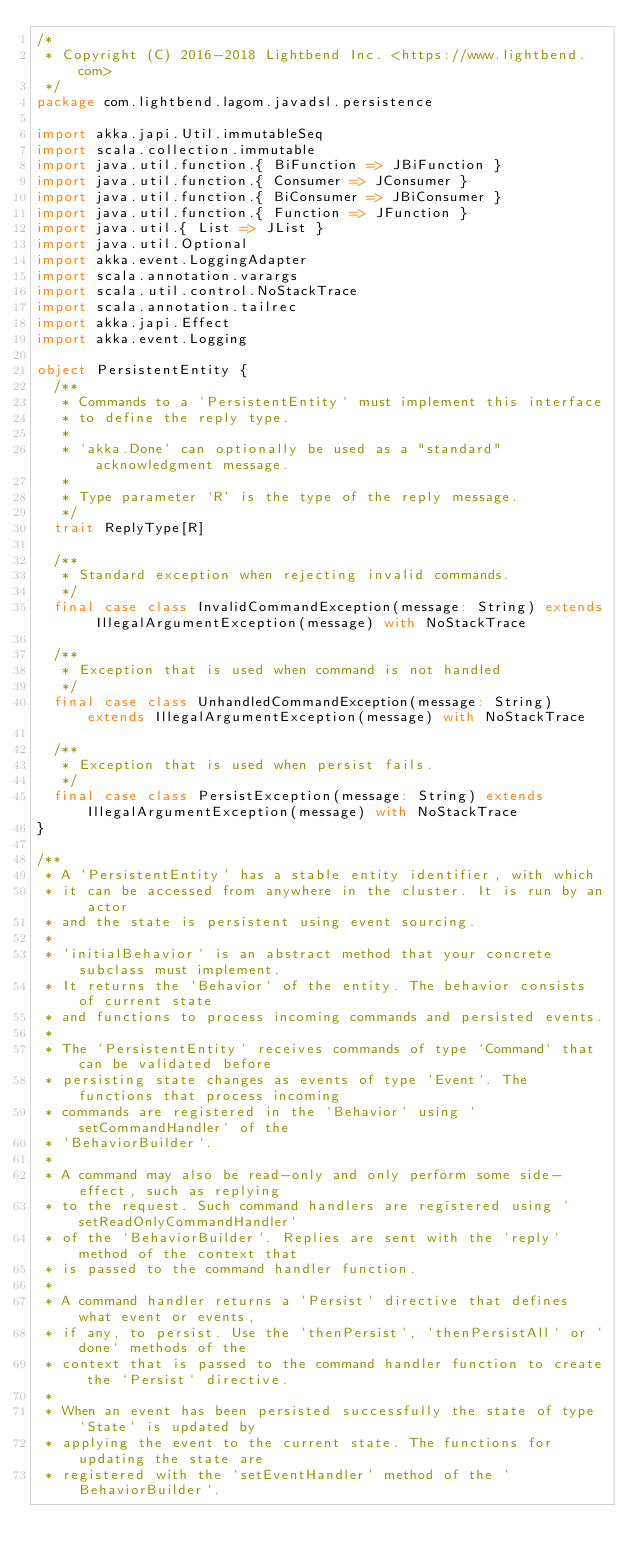Convert code to text. <code><loc_0><loc_0><loc_500><loc_500><_Scala_>/*
 * Copyright (C) 2016-2018 Lightbend Inc. <https://www.lightbend.com>
 */
package com.lightbend.lagom.javadsl.persistence

import akka.japi.Util.immutableSeq
import scala.collection.immutable
import java.util.function.{ BiFunction => JBiFunction }
import java.util.function.{ Consumer => JConsumer }
import java.util.function.{ BiConsumer => JBiConsumer }
import java.util.function.{ Function => JFunction }
import java.util.{ List => JList }
import java.util.Optional
import akka.event.LoggingAdapter
import scala.annotation.varargs
import scala.util.control.NoStackTrace
import scala.annotation.tailrec
import akka.japi.Effect
import akka.event.Logging

object PersistentEntity {
  /**
   * Commands to a `PersistentEntity` must implement this interface
   * to define the reply type.
   *
   * `akka.Done` can optionally be used as a "standard" acknowledgment message.
   *
   * Type parameter `R` is the type of the reply message.
   */
  trait ReplyType[R]

  /**
   * Standard exception when rejecting invalid commands.
   */
  final case class InvalidCommandException(message: String) extends IllegalArgumentException(message) with NoStackTrace

  /**
   * Exception that is used when command is not handled
   */
  final case class UnhandledCommandException(message: String) extends IllegalArgumentException(message) with NoStackTrace

  /**
   * Exception that is used when persist fails.
   */
  final case class PersistException(message: String) extends IllegalArgumentException(message) with NoStackTrace
}

/**
 * A `PersistentEntity` has a stable entity identifier, with which
 * it can be accessed from anywhere in the cluster. It is run by an actor
 * and the state is persistent using event sourcing.
 *
 * `initialBehavior` is an abstract method that your concrete subclass must implement.
 * It returns the `Behavior` of the entity. The behavior consists of current state
 * and functions to process incoming commands and persisted events.
 *
 * The `PersistentEntity` receives commands of type `Command` that can be validated before
 * persisting state changes as events of type `Event`. The functions that process incoming
 * commands are registered in the `Behavior` using `setCommandHandler` of the
 * `BehaviorBuilder`.
 *
 * A command may also be read-only and only perform some side-effect, such as replying
 * to the request. Such command handlers are registered using `setReadOnlyCommandHandler`
 * of the `BehaviorBuilder`. Replies are sent with the `reply` method of the context that
 * is passed to the command handler function.
 *
 * A command handler returns a `Persist` directive that defines what event or events,
 * if any, to persist. Use the `thenPersist`, `thenPersistAll` or `done` methods of the
 * context that is passed to the command handler function to create the `Persist` directive.
 *
 * When an event has been persisted successfully the state of type `State` is updated by
 * applying the event to the current state. The functions for updating the state are
 * registered with the `setEventHandler` method of the `BehaviorBuilder`.</code> 